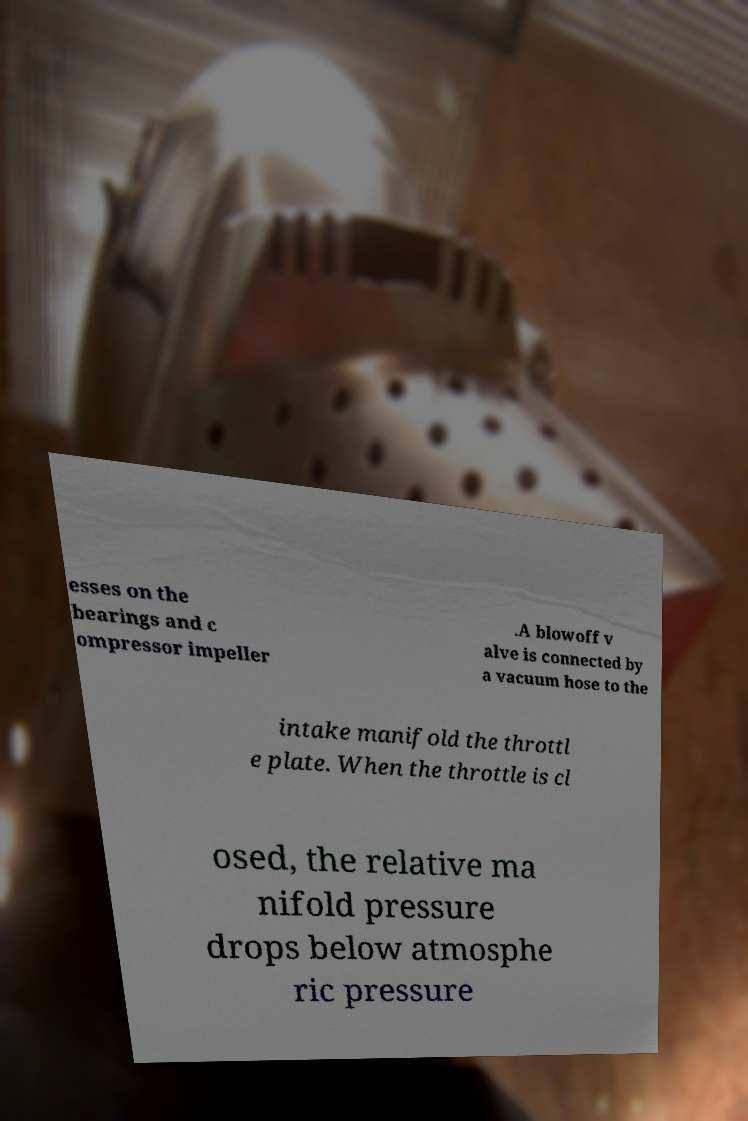For documentation purposes, I need the text within this image transcribed. Could you provide that? esses on the bearings and c ompressor impeller .A blowoff v alve is connected by a vacuum hose to the intake manifold the throttl e plate. When the throttle is cl osed, the relative ma nifold pressure drops below atmosphe ric pressure 